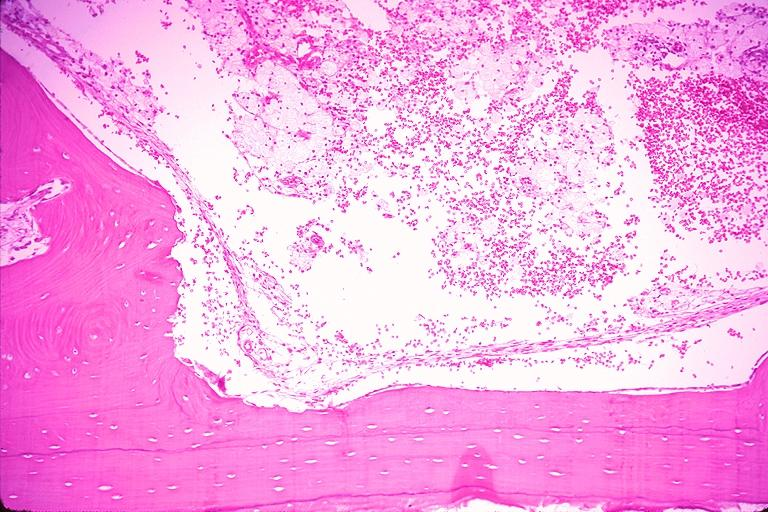s histoplasmosis present?
Answer the question using a single word or phrase. No 